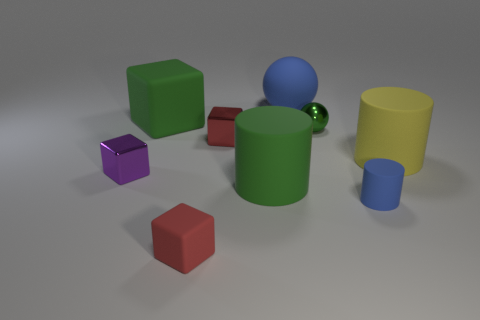Is the shape of the yellow matte thing that is in front of the big block the same as  the tiny blue matte thing?
Ensure brevity in your answer.  Yes. How many other tiny rubber objects have the same shape as the purple object?
Make the answer very short. 1. Are there any brown balls made of the same material as the small blue object?
Offer a very short reply. No. The red thing behind the green object that is in front of the purple object is made of what material?
Give a very brief answer. Metal. How big is the red block that is on the right side of the tiny matte cube?
Provide a succinct answer. Small. Does the small matte cube have the same color as the small metallic cube that is behind the purple metallic cube?
Make the answer very short. Yes. Is there a rubber cylinder that has the same color as the metallic ball?
Offer a very short reply. Yes. Is the material of the small green thing the same as the red object behind the tiny red matte block?
Ensure brevity in your answer.  Yes. How many small things are blue objects or red rubber things?
Your response must be concise. 2. What is the material of the cylinder that is the same color as the shiny sphere?
Offer a terse response. Rubber. 